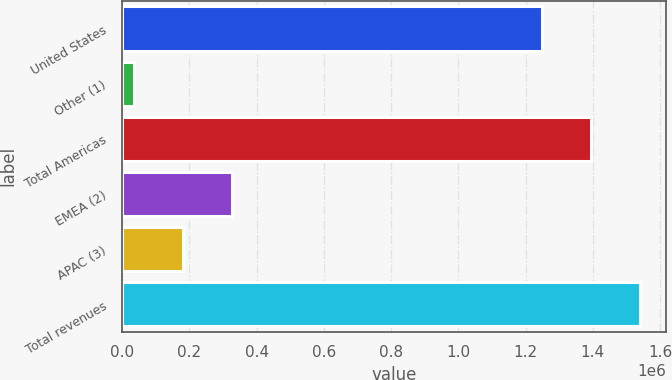Convert chart to OTSL. <chart><loc_0><loc_0><loc_500><loc_500><bar_chart><fcel>United States<fcel>Other (1)<fcel>Total Americas<fcel>EMEA (2)<fcel>APAC (3)<fcel>Total revenues<nl><fcel>1.24807e+06<fcel>34028<fcel>1.3943e+06<fcel>326480<fcel>180254<fcel>1.54052e+06<nl></chart> 